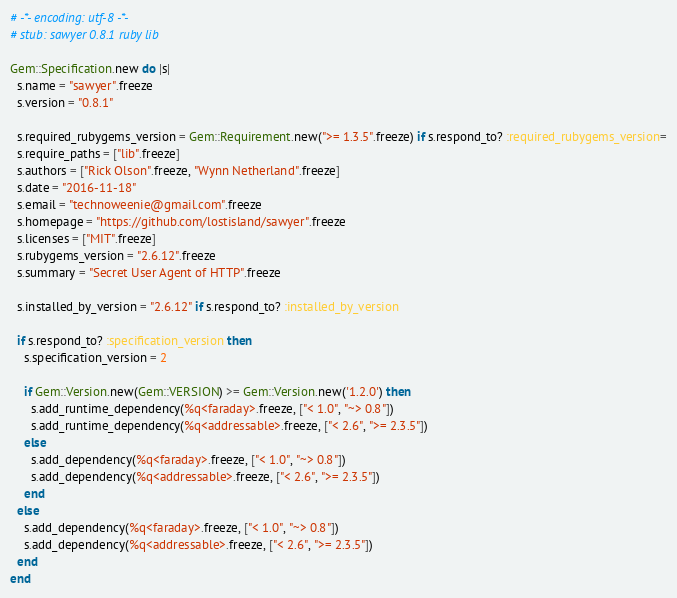<code> <loc_0><loc_0><loc_500><loc_500><_Ruby_># -*- encoding: utf-8 -*-
# stub: sawyer 0.8.1 ruby lib

Gem::Specification.new do |s|
  s.name = "sawyer".freeze
  s.version = "0.8.1"

  s.required_rubygems_version = Gem::Requirement.new(">= 1.3.5".freeze) if s.respond_to? :required_rubygems_version=
  s.require_paths = ["lib".freeze]
  s.authors = ["Rick Olson".freeze, "Wynn Netherland".freeze]
  s.date = "2016-11-18"
  s.email = "technoweenie@gmail.com".freeze
  s.homepage = "https://github.com/lostisland/sawyer".freeze
  s.licenses = ["MIT".freeze]
  s.rubygems_version = "2.6.12".freeze
  s.summary = "Secret User Agent of HTTP".freeze

  s.installed_by_version = "2.6.12" if s.respond_to? :installed_by_version

  if s.respond_to? :specification_version then
    s.specification_version = 2

    if Gem::Version.new(Gem::VERSION) >= Gem::Version.new('1.2.0') then
      s.add_runtime_dependency(%q<faraday>.freeze, ["< 1.0", "~> 0.8"])
      s.add_runtime_dependency(%q<addressable>.freeze, ["< 2.6", ">= 2.3.5"])
    else
      s.add_dependency(%q<faraday>.freeze, ["< 1.0", "~> 0.8"])
      s.add_dependency(%q<addressable>.freeze, ["< 2.6", ">= 2.3.5"])
    end
  else
    s.add_dependency(%q<faraday>.freeze, ["< 1.0", "~> 0.8"])
    s.add_dependency(%q<addressable>.freeze, ["< 2.6", ">= 2.3.5"])
  end
end
</code> 